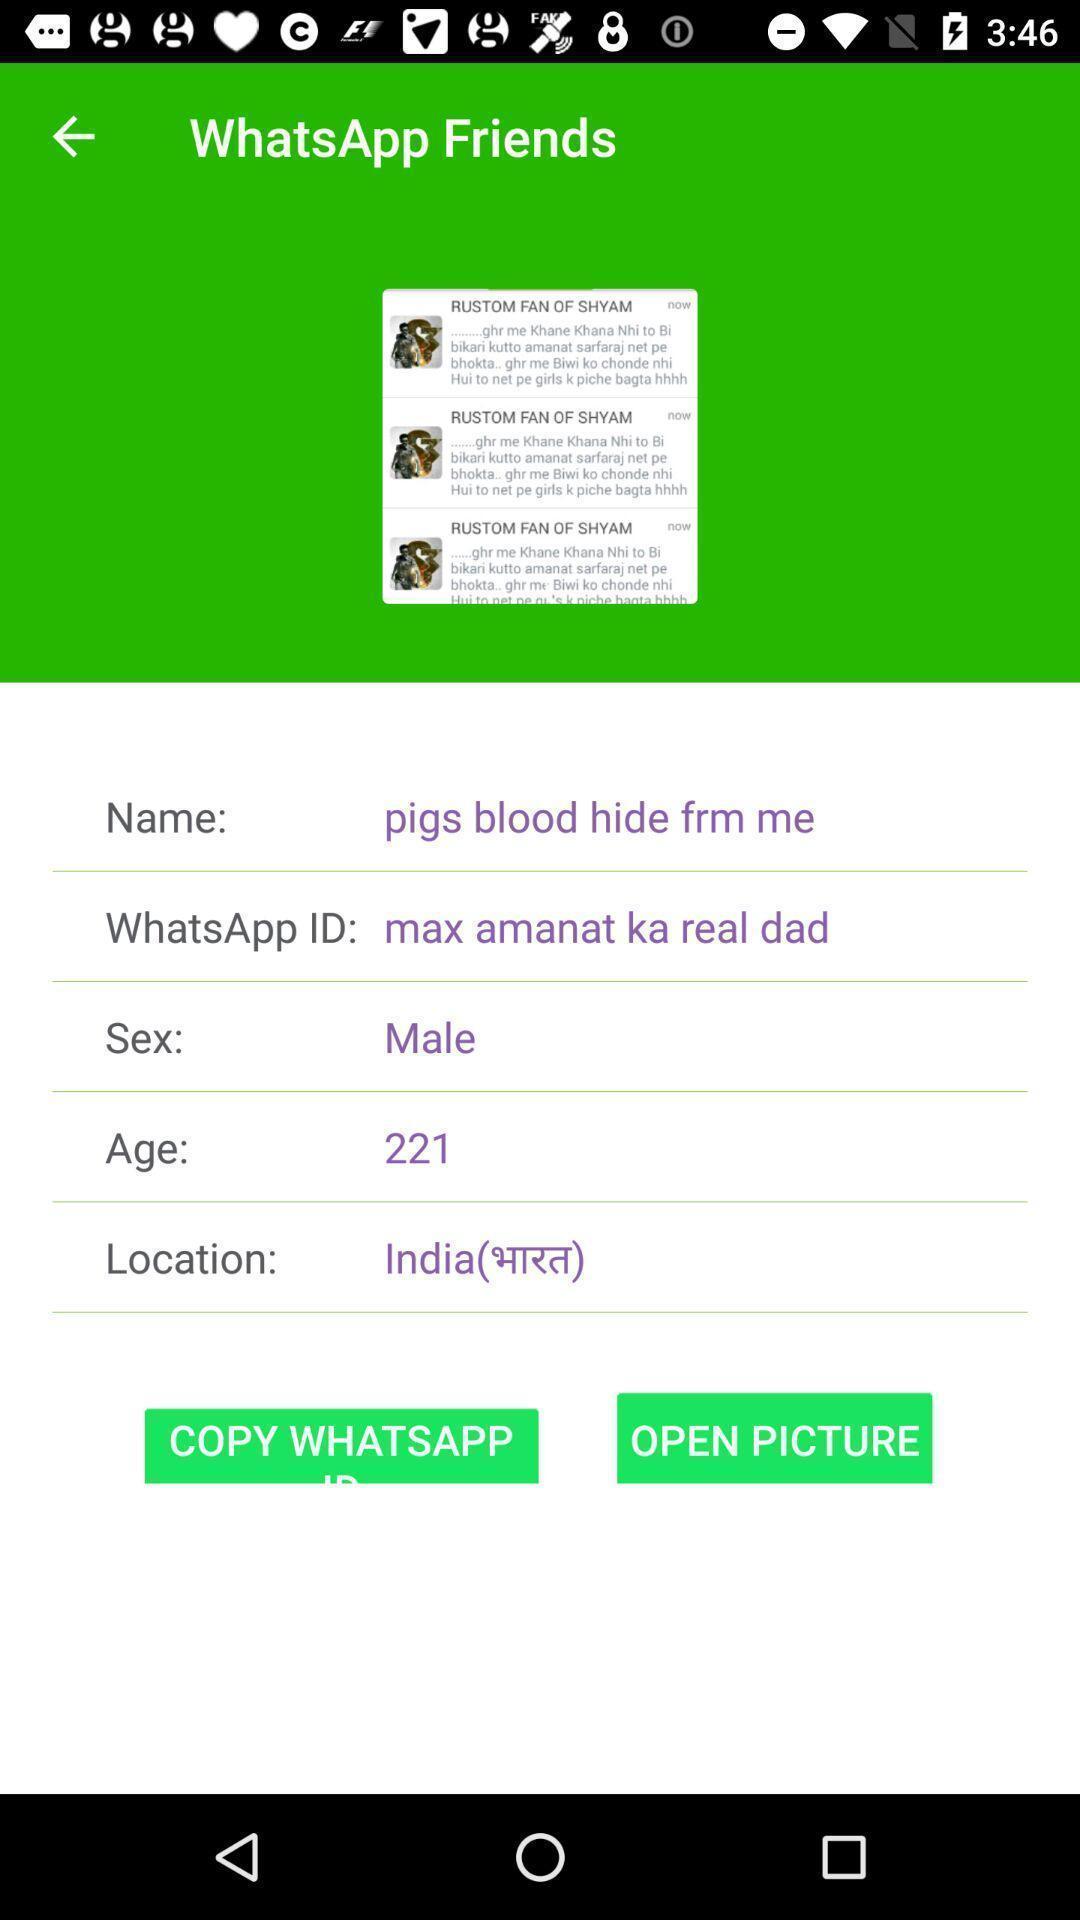Describe this image in words. Screen showing profile details of a person. 